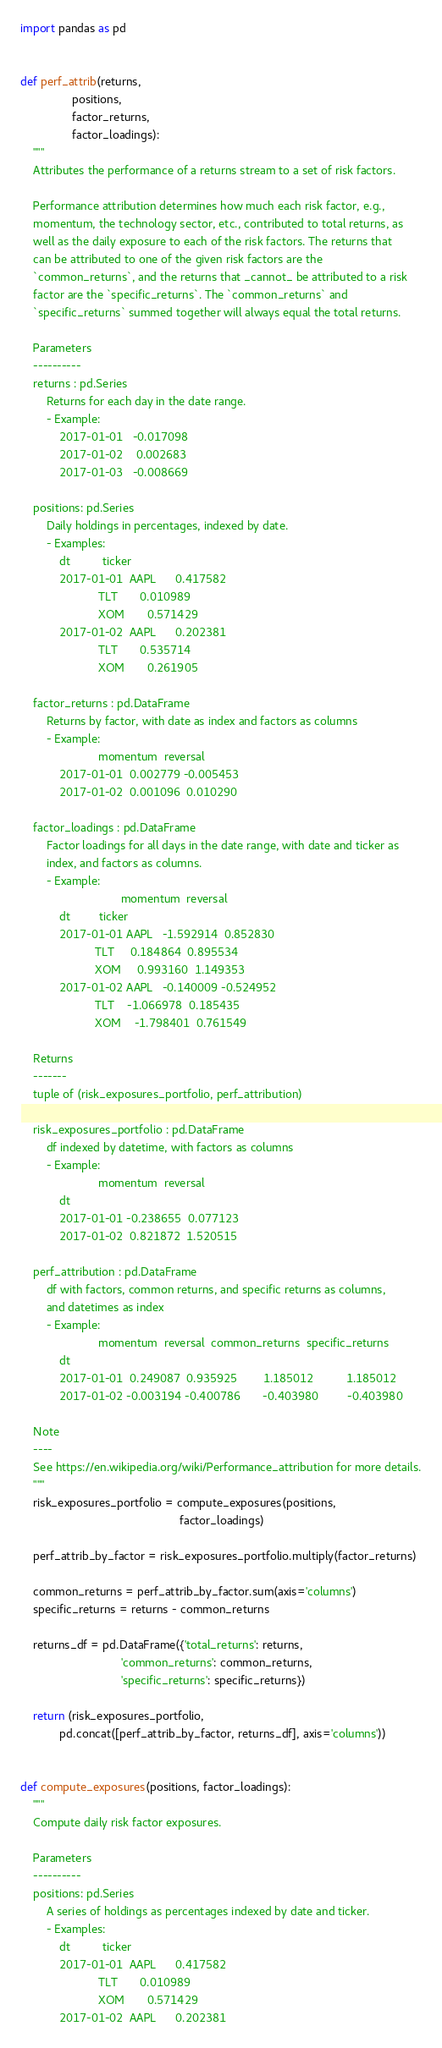<code> <loc_0><loc_0><loc_500><loc_500><_Python_>import pandas as pd


def perf_attrib(returns,
                positions,
                factor_returns,
                factor_loadings):
    """
    Attributes the performance of a returns stream to a set of risk factors.

    Performance attribution determines how much each risk factor, e.g.,
    momentum, the technology sector, etc., contributed to total returns, as
    well as the daily exposure to each of the risk factors. The returns that
    can be attributed to one of the given risk factors are the
    `common_returns`, and the returns that _cannot_ be attributed to a risk
    factor are the `specific_returns`. The `common_returns` and
    `specific_returns` summed together will always equal the total returns.

    Parameters
    ----------
    returns : pd.Series
        Returns for each day in the date range.
        - Example:
            2017-01-01   -0.017098
            2017-01-02    0.002683
            2017-01-03   -0.008669

    positions: pd.Series
        Daily holdings in percentages, indexed by date.
        - Examples:
            dt          ticker
            2017-01-01  AAPL      0.417582
                        TLT       0.010989
                        XOM       0.571429
            2017-01-02  AAPL      0.202381
                        TLT       0.535714
                        XOM       0.261905

    factor_returns : pd.DataFrame
        Returns by factor, with date as index and factors as columns
        - Example:
                        momentum  reversal
            2017-01-01  0.002779 -0.005453
            2017-01-02  0.001096  0.010290

    factor_loadings : pd.DataFrame
        Factor loadings for all days in the date range, with date and ticker as
        index, and factors as columns.
        - Example:
                               momentum  reversal
            dt         ticker
            2017-01-01 AAPL   -1.592914  0.852830
                       TLT     0.184864  0.895534
                       XOM     0.993160  1.149353
            2017-01-02 AAPL   -0.140009 -0.524952
                       TLT    -1.066978  0.185435
                       XOM    -1.798401  0.761549

    Returns
    -------
    tuple of (risk_exposures_portfolio, perf_attribution)

    risk_exposures_portfolio : pd.DataFrame
        df indexed by datetime, with factors as columns
        - Example:
                        momentum  reversal
            dt
            2017-01-01 -0.238655  0.077123
            2017-01-02  0.821872  1.520515

    perf_attribution : pd.DataFrame
        df with factors, common returns, and specific returns as columns,
        and datetimes as index
        - Example:
                        momentum  reversal  common_returns  specific_returns
            dt
            2017-01-01  0.249087  0.935925        1.185012          1.185012
            2017-01-02 -0.003194 -0.400786       -0.403980         -0.403980

    Note
    ----
    See https://en.wikipedia.org/wiki/Performance_attribution for more details.
    """
    risk_exposures_portfolio = compute_exposures(positions,
                                                 factor_loadings)

    perf_attrib_by_factor = risk_exposures_portfolio.multiply(factor_returns)

    common_returns = perf_attrib_by_factor.sum(axis='columns')
    specific_returns = returns - common_returns

    returns_df = pd.DataFrame({'total_returns': returns,
                               'common_returns': common_returns,
                               'specific_returns': specific_returns})

    return (risk_exposures_portfolio,
            pd.concat([perf_attrib_by_factor, returns_df], axis='columns'))


def compute_exposures(positions, factor_loadings):
    """
    Compute daily risk factor exposures.

    Parameters
    ----------
    positions: pd.Series
        A series of holdings as percentages indexed by date and ticker.
        - Examples:
            dt          ticker
            2017-01-01  AAPL      0.417582
                        TLT       0.010989
                        XOM       0.571429
            2017-01-02  AAPL      0.202381</code> 